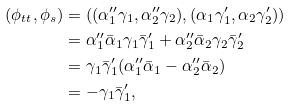Convert formula to latex. <formula><loc_0><loc_0><loc_500><loc_500>( \phi _ { t t } , \phi _ { s } ) & = ( ( \alpha ^ { \prime \prime } _ { 1 } \gamma _ { 1 } , \alpha ^ { \prime \prime } _ { 2 } \gamma _ { 2 } ) , ( \alpha _ { 1 } \gamma _ { 1 } ^ { \prime } , \alpha _ { 2 } \gamma ^ { \prime } _ { 2 } ) ) \\ & = \alpha ^ { \prime \prime } _ { 1 } \bar { \alpha } _ { 1 } \gamma _ { 1 } \bar { \gamma } ^ { \prime } _ { 1 } + \alpha ^ { \prime \prime } _ { 2 } \bar { \alpha } _ { 2 } \gamma _ { 2 } \bar { \gamma } ^ { \prime } _ { 2 } \\ & = \gamma _ { 1 } \bar { \gamma } ^ { \prime } _ { 1 } ( \alpha ^ { \prime \prime } _ { 1 } \bar { \alpha } _ { 1 } - \alpha ^ { \prime \prime } _ { 2 } \bar { \alpha } _ { 2 } ) \\ & = - \gamma _ { 1 } \bar { \gamma } ^ { \prime } _ { 1 } ,</formula> 